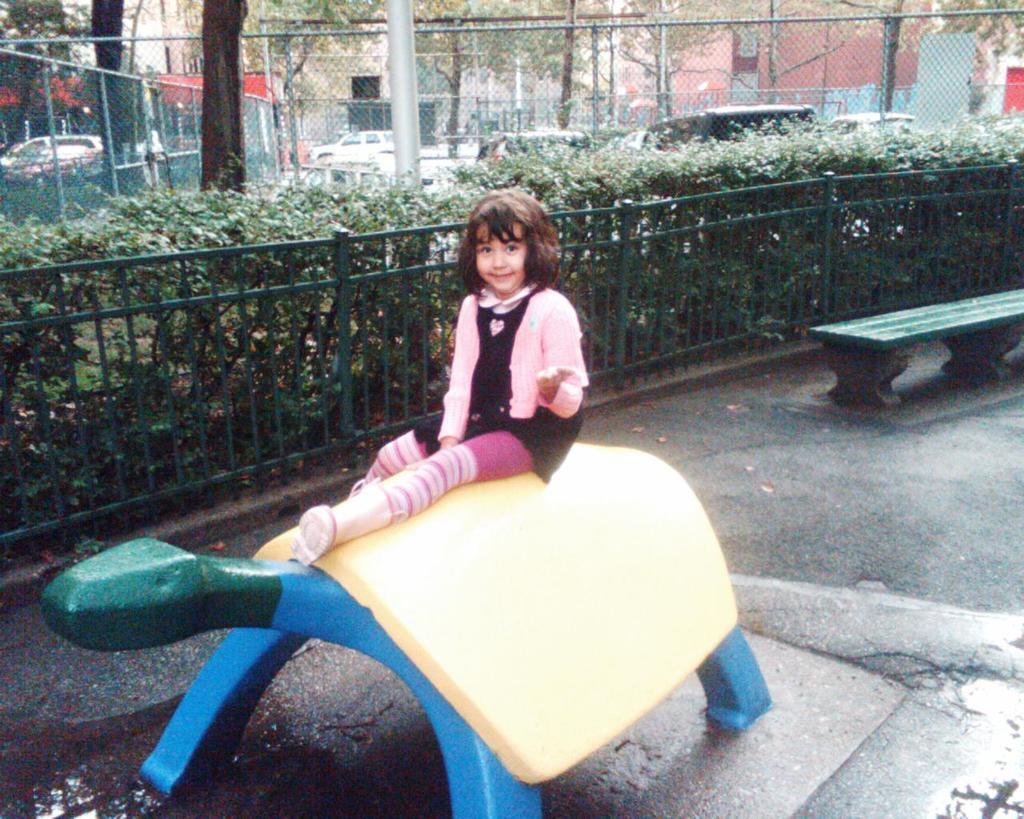Describe this image in one or two sentences. In this image I can see a bench and here I can see a girl is sitting. I can see she is wearing pink and black colour dress. In the background I can see fencing, plants, number of vehicles, few poles, few trees and few buildings. 